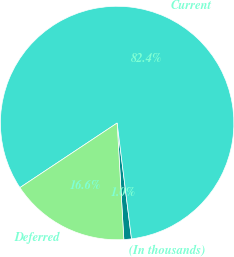Convert chart. <chart><loc_0><loc_0><loc_500><loc_500><pie_chart><fcel>(In thousands)<fcel>Current<fcel>Deferred<nl><fcel>1.05%<fcel>82.37%<fcel>16.58%<nl></chart> 